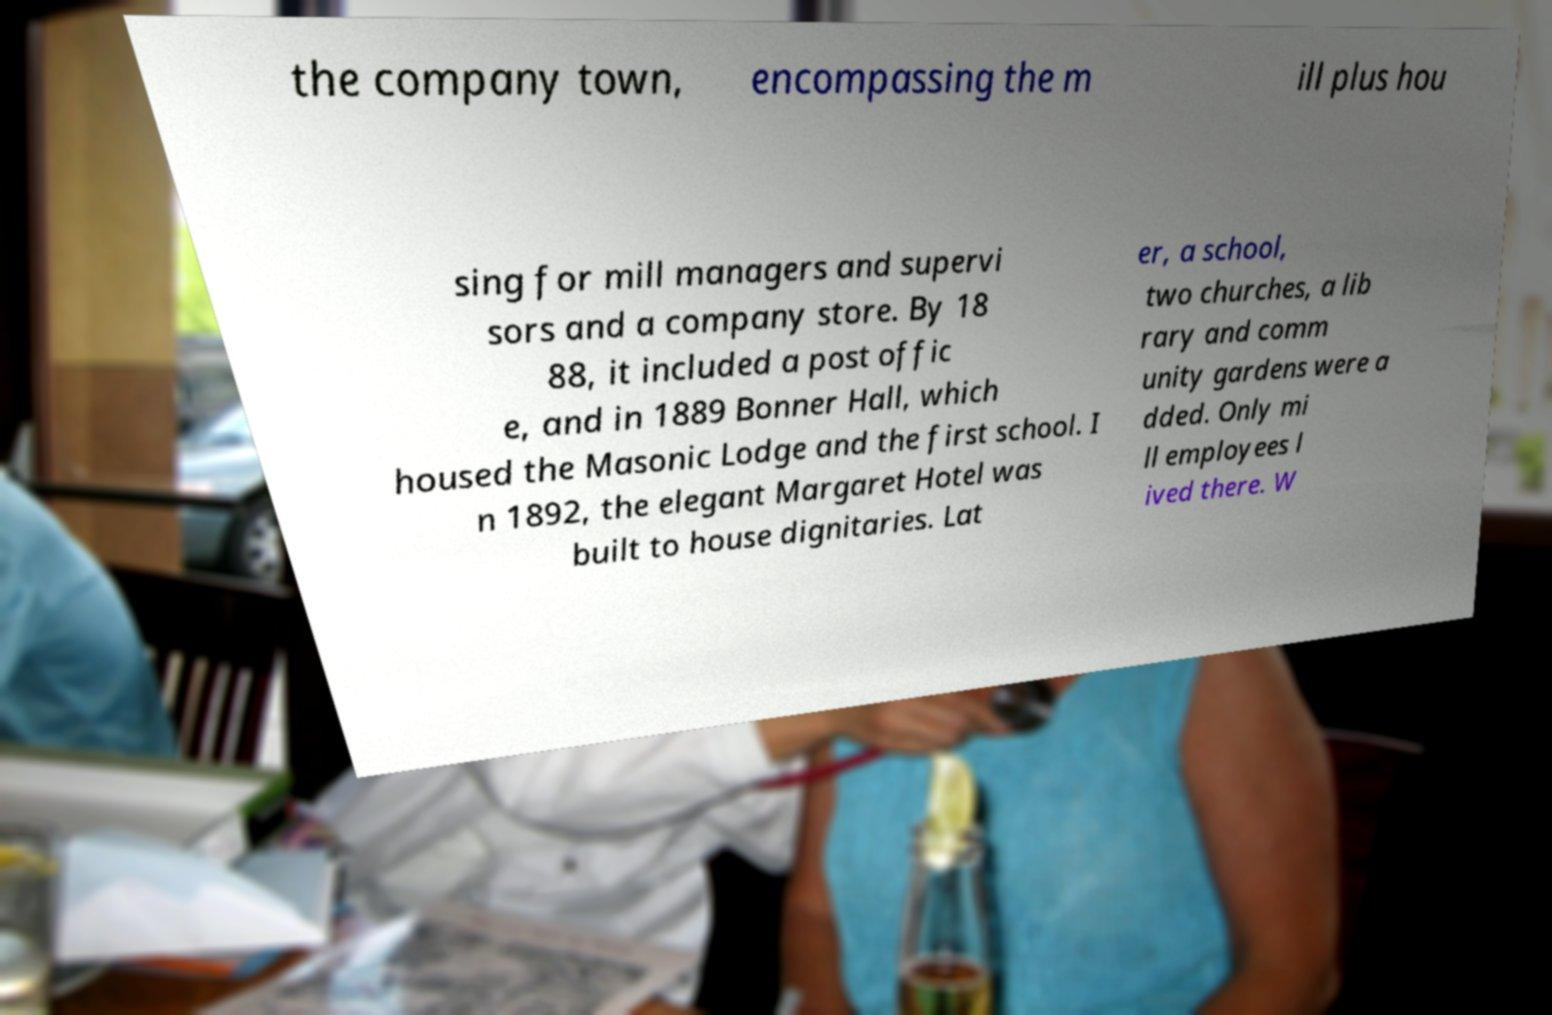What messages or text are displayed in this image? I need them in a readable, typed format. the company town, encompassing the m ill plus hou sing for mill managers and supervi sors and a company store. By 18 88, it included a post offic e, and in 1889 Bonner Hall, which housed the Masonic Lodge and the first school. I n 1892, the elegant Margaret Hotel was built to house dignitaries. Lat er, a school, two churches, a lib rary and comm unity gardens were a dded. Only mi ll employees l ived there. W 